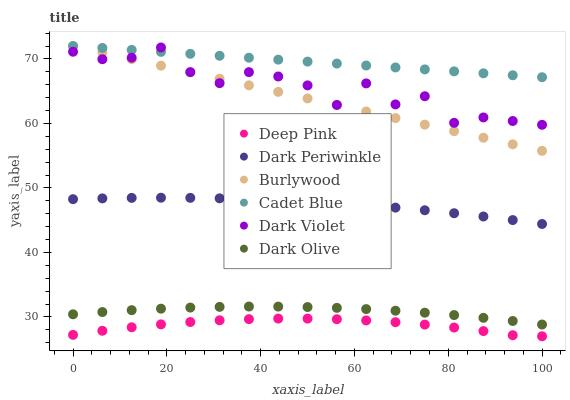Does Deep Pink have the minimum area under the curve?
Answer yes or no. Yes. Does Cadet Blue have the maximum area under the curve?
Answer yes or no. Yes. Does Burlywood have the minimum area under the curve?
Answer yes or no. No. Does Burlywood have the maximum area under the curve?
Answer yes or no. No. Is Burlywood the smoothest?
Answer yes or no. Yes. Is Dark Violet the roughest?
Answer yes or no. Yes. Is Dark Olive the smoothest?
Answer yes or no. No. Is Dark Olive the roughest?
Answer yes or no. No. Does Deep Pink have the lowest value?
Answer yes or no. Yes. Does Burlywood have the lowest value?
Answer yes or no. No. Does Cadet Blue have the highest value?
Answer yes or no. Yes. Does Dark Olive have the highest value?
Answer yes or no. No. Is Deep Pink less than Dark Periwinkle?
Answer yes or no. Yes. Is Cadet Blue greater than Dark Olive?
Answer yes or no. Yes. Does Burlywood intersect Dark Violet?
Answer yes or no. Yes. Is Burlywood less than Dark Violet?
Answer yes or no. No. Is Burlywood greater than Dark Violet?
Answer yes or no. No. Does Deep Pink intersect Dark Periwinkle?
Answer yes or no. No. 